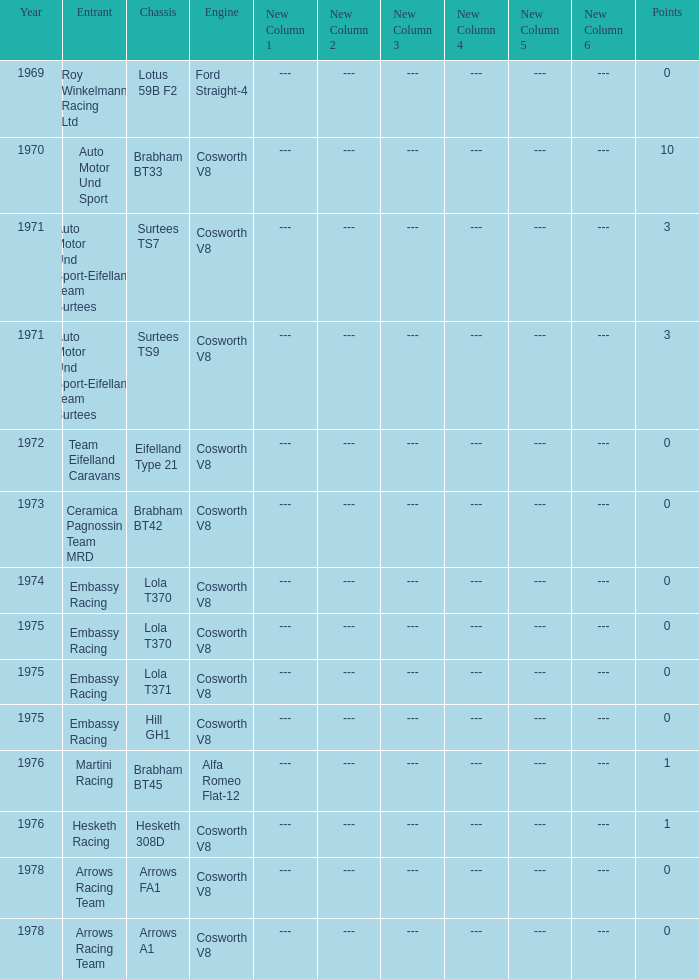Who was the entrant in 1971? Auto Motor Und Sport-Eifelland Team Surtees, Auto Motor Und Sport-Eifelland Team Surtees. 